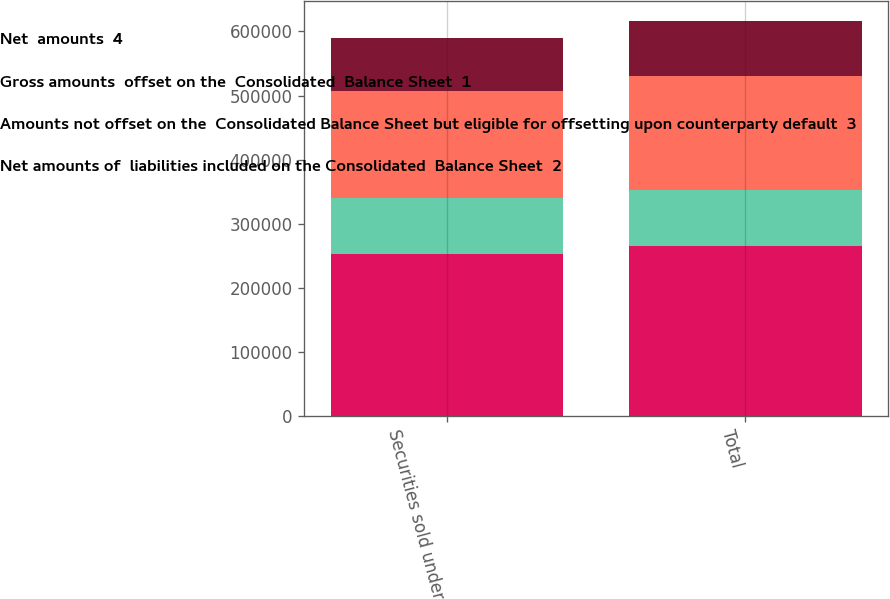Convert chart to OTSL. <chart><loc_0><loc_0><loc_500><loc_500><stacked_bar_chart><ecel><fcel>Securities sold under<fcel>Total<nl><fcel>Net  amounts  4<fcel>253514<fcel>265192<nl><fcel>Gross amounts  offset on the  Consolidated  Balance Sheet  1<fcel>87424<fcel>87424<nl><fcel>Amounts not offset on the  Consolidated Balance Sheet but eligible for offsetting upon counterparty default  3<fcel>166090<fcel>177768<nl><fcel>Net amounts of  liabilities included on the Consolidated  Balance Sheet  2<fcel>82823<fcel>86238<nl></chart> 